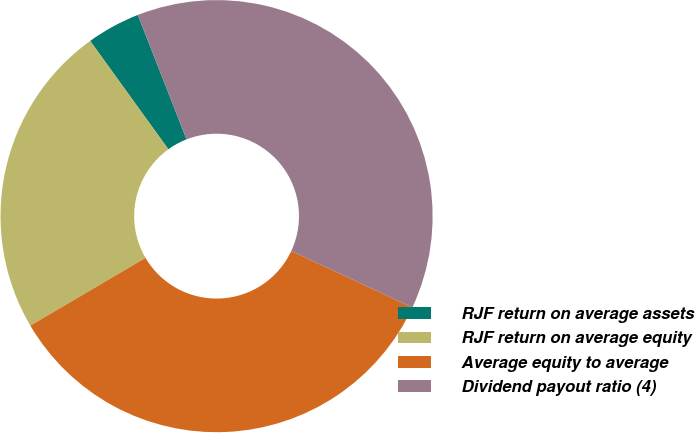Convert chart. <chart><loc_0><loc_0><loc_500><loc_500><pie_chart><fcel>RJF return on average assets<fcel>RJF return on average equity<fcel>Average equity to average<fcel>Dividend payout ratio (4)<nl><fcel>4.01%<fcel>23.51%<fcel>34.59%<fcel>37.88%<nl></chart> 